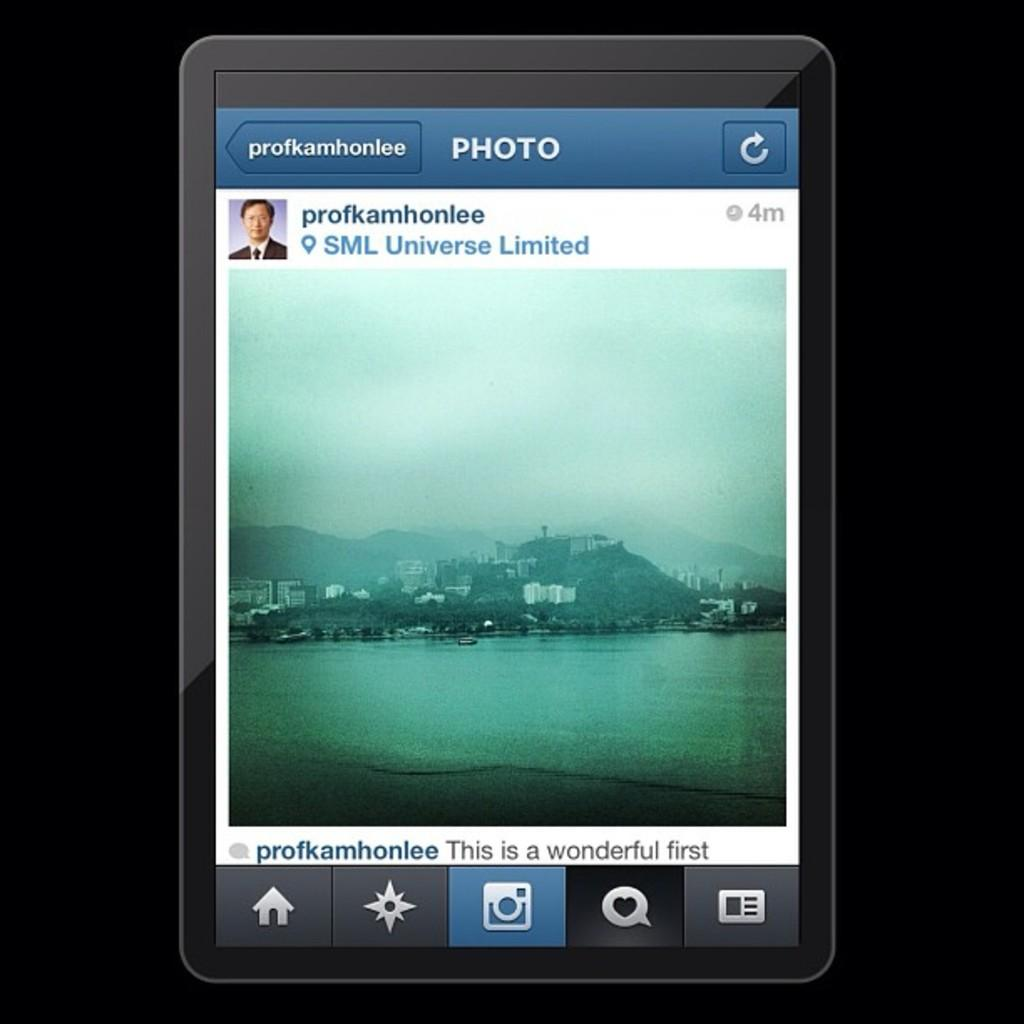<image>
Offer a succinct explanation of the picture presented. tablet with a photo posting of an island on it from profkamhonlee 